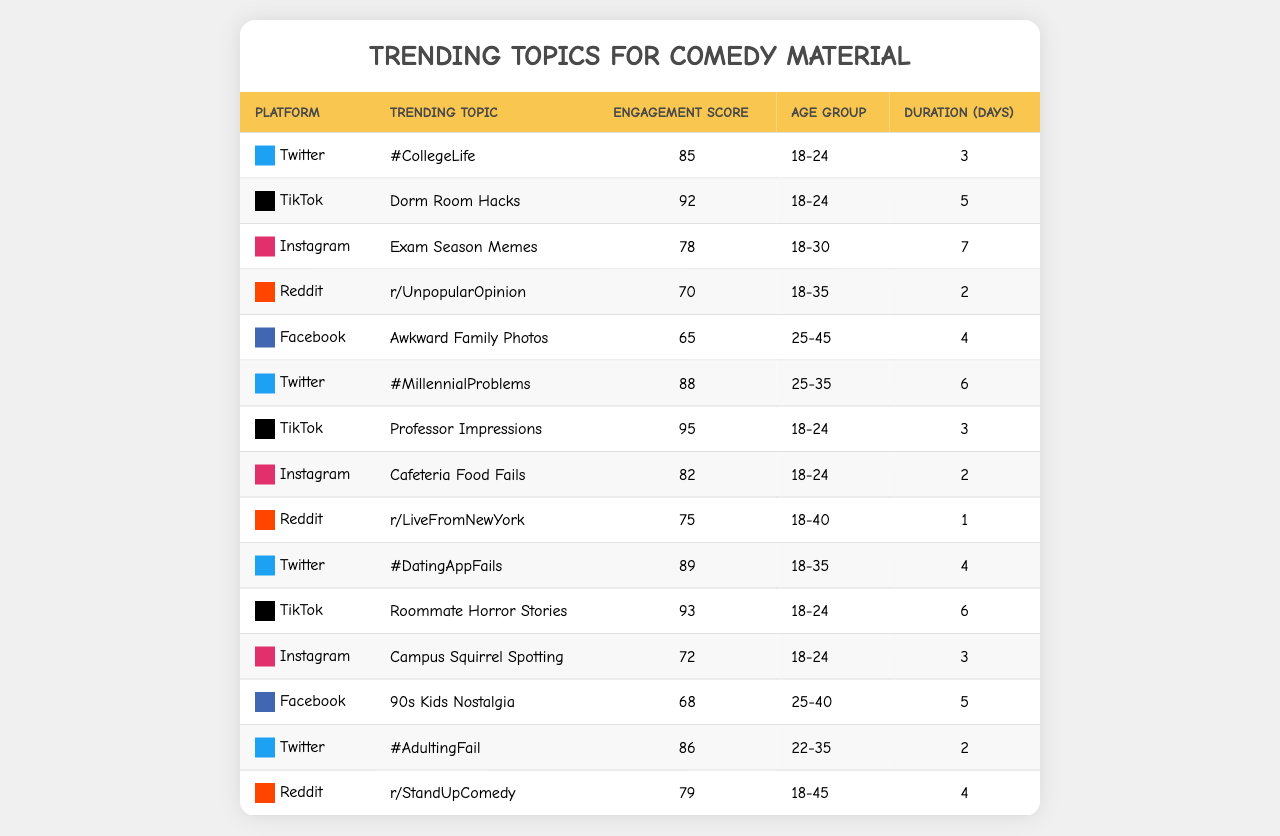What is the trending topic with the highest engagement score? The table lists engagement scores for each topic, and the highest score is 95 associated with "Professor Impressions" on TikTok.
Answer: Professor Impressions Which platform has the most trending topics targeted at the 18-24 age group? By reviewing the table, both Twitter and TikTok have multiple entries for the 18-24 age group: Twitter has 3 and TikTok has 3. Combining those, they are tied for the highest.
Answer: Twitter and TikTok Is the engagement score for "Awkward Family Photos" higher than "Exam Season Memes"? The engagement score for "Awkward Family Photos" is 65 while for "Exam Season Memes" it is 78. 65 is less than 78, so the statement is false.
Answer: No What is the average engagement score for topics related to the 18-24 age group? The scores for 18-24 age group topics are 85, 92, 95, 93, and 82. Sum those scores: 85 + 92 + 95 + 93 + 82 = 447. There are 5 scores, so the average is 447 / 5 = 89.4.
Answer: 89.4 Which trending topics last for more than four days? By scanning the Duration column, the topics "Dorm Room Hacks" (5 days), "Exam Season Memes" (7 days), and "90s Kids Nostalgia" (5 days) all have a duration higher than four days.
Answer: Dorm Room Hacks, Exam Season Memes, 90s Kids Nostalgia Are there more trending topics related to Twitter or TikTok? Counting the entries in the table, Twitter has 5 trending topics while TikTok has 4. Therefore, there are more topics related to Twitter.
Answer: Yes, more for Twitter Which topic has the lowest engagement score and what is that score? Looking at the engagement scores listed, the lowest score is 65 for "Awkward Family Photos".
Answer: 65 How many platforms have a trending topic with an engagement score of 90 or higher? The topics with scores of 90 or more are: "Dorm Room Hacks", "Professor Impressions", and "Roommate Horror Stories". These are on TikTok and are 3 entries total. The number of platforms is 2: Twitter and TikTok.
Answer: 2 platforms What is the duration difference between "#AdultingFail" and "r/LiveFromNewYork"? The duration for "#AdultingFail" is 2 days while "r/LiveFromNewYork" is 1 day. The difference is 2 - 1 = 1 day.
Answer: 1 day Is it true that "Cafeteria Food Fails" has an engagement score of 80 or more? The engagement score for "Cafeteria Food Fails" is 82, which is indeed 80 or more. Therefore, the statement is true.
Answer: Yes 